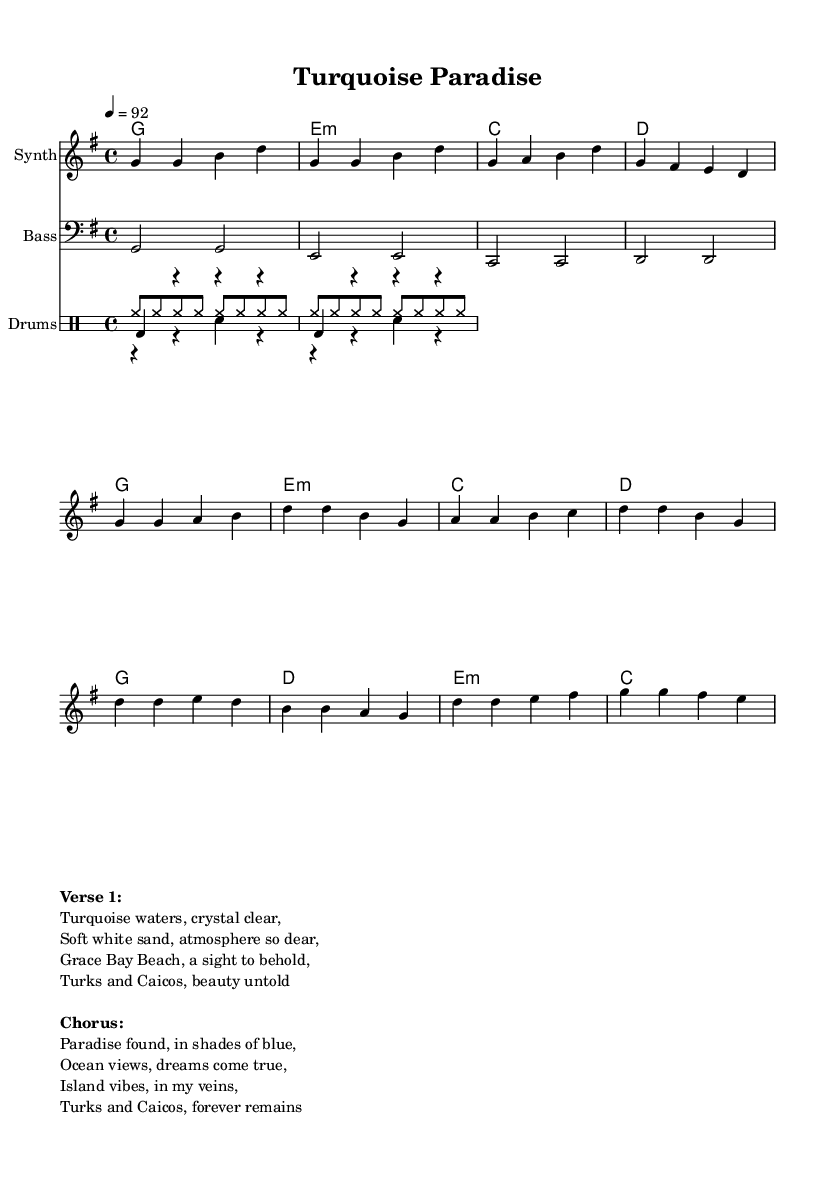What is the key signature of this music? The key signature is G major, which is indicated by one sharp (F#).
Answer: G major What is the time signature of this music? The time signature is 4/4, which means there are four beats in each measure and the quarter note gets one beat.
Answer: 4/4 What is the tempo marking for this piece? The tempo marking indicates a speed of 92 beats per minute, which suggests a moderate pace typical for hip hop.
Answer: 92 How many measures are in the intro section? The intro consists of 4 measures with a specific melody and chord progression.
Answer: 4 What is the main theme described in the chorus? The chorus refers to the beauty of the island, focusing on ocean views and paradise found, which is characteristic of celebrating the Turks and Caicos.
Answer: Paradise found Which element defines the genre of this music? The use of a prominent drum beat, characterized by the kick, snare, and hi-hat patterns, is essential in hip hop, providing rhythm and drive.
Answer: Drum patterns What is the name of the piece? The title of the piece, reflecting its content, is "Turquoise Paradise."
Answer: Turquoise Paradise 